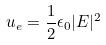<formula> <loc_0><loc_0><loc_500><loc_500>u _ { e } = \frac { 1 } { 2 } \epsilon _ { 0 } | E | ^ { 2 }</formula> 